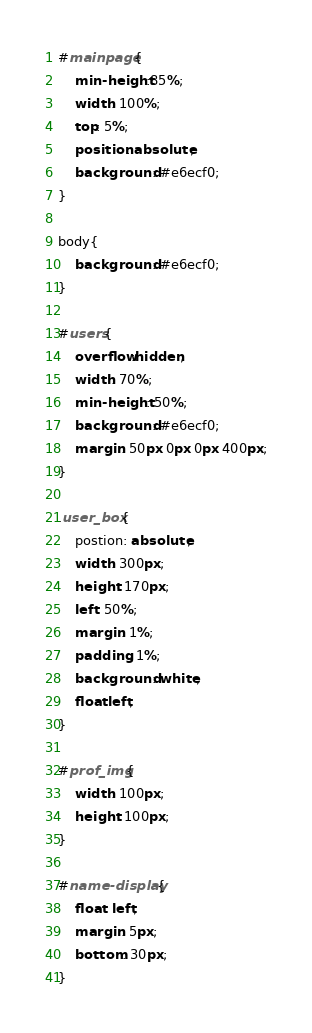Convert code to text. <code><loc_0><loc_0><loc_500><loc_500><_CSS_>#mainpage{
    min-height:85%;
    width: 100%;
    top: 5%;
    position: absolute;
    background: #e6ecf0;
}

body{
    background: #e6ecf0;
}

#users{
    overflow:hidden;
    width: 70%;
    min-height: 50%;
    background: #e6ecf0;
    margin: 50px 0px 0px 400px;
}

.user_box{
    postion: absolute;
    width: 300px;
    height: 170px;
    left: 50%;
    margin: 1%;
    padding: 1%;
    background: white;
    float:left;
}

#prof_img{
    width: 100px;
    height: 100px;
}

#name-display{
    float: left;
    margin: 5px;
    bottom: 30px;
}


</code> 